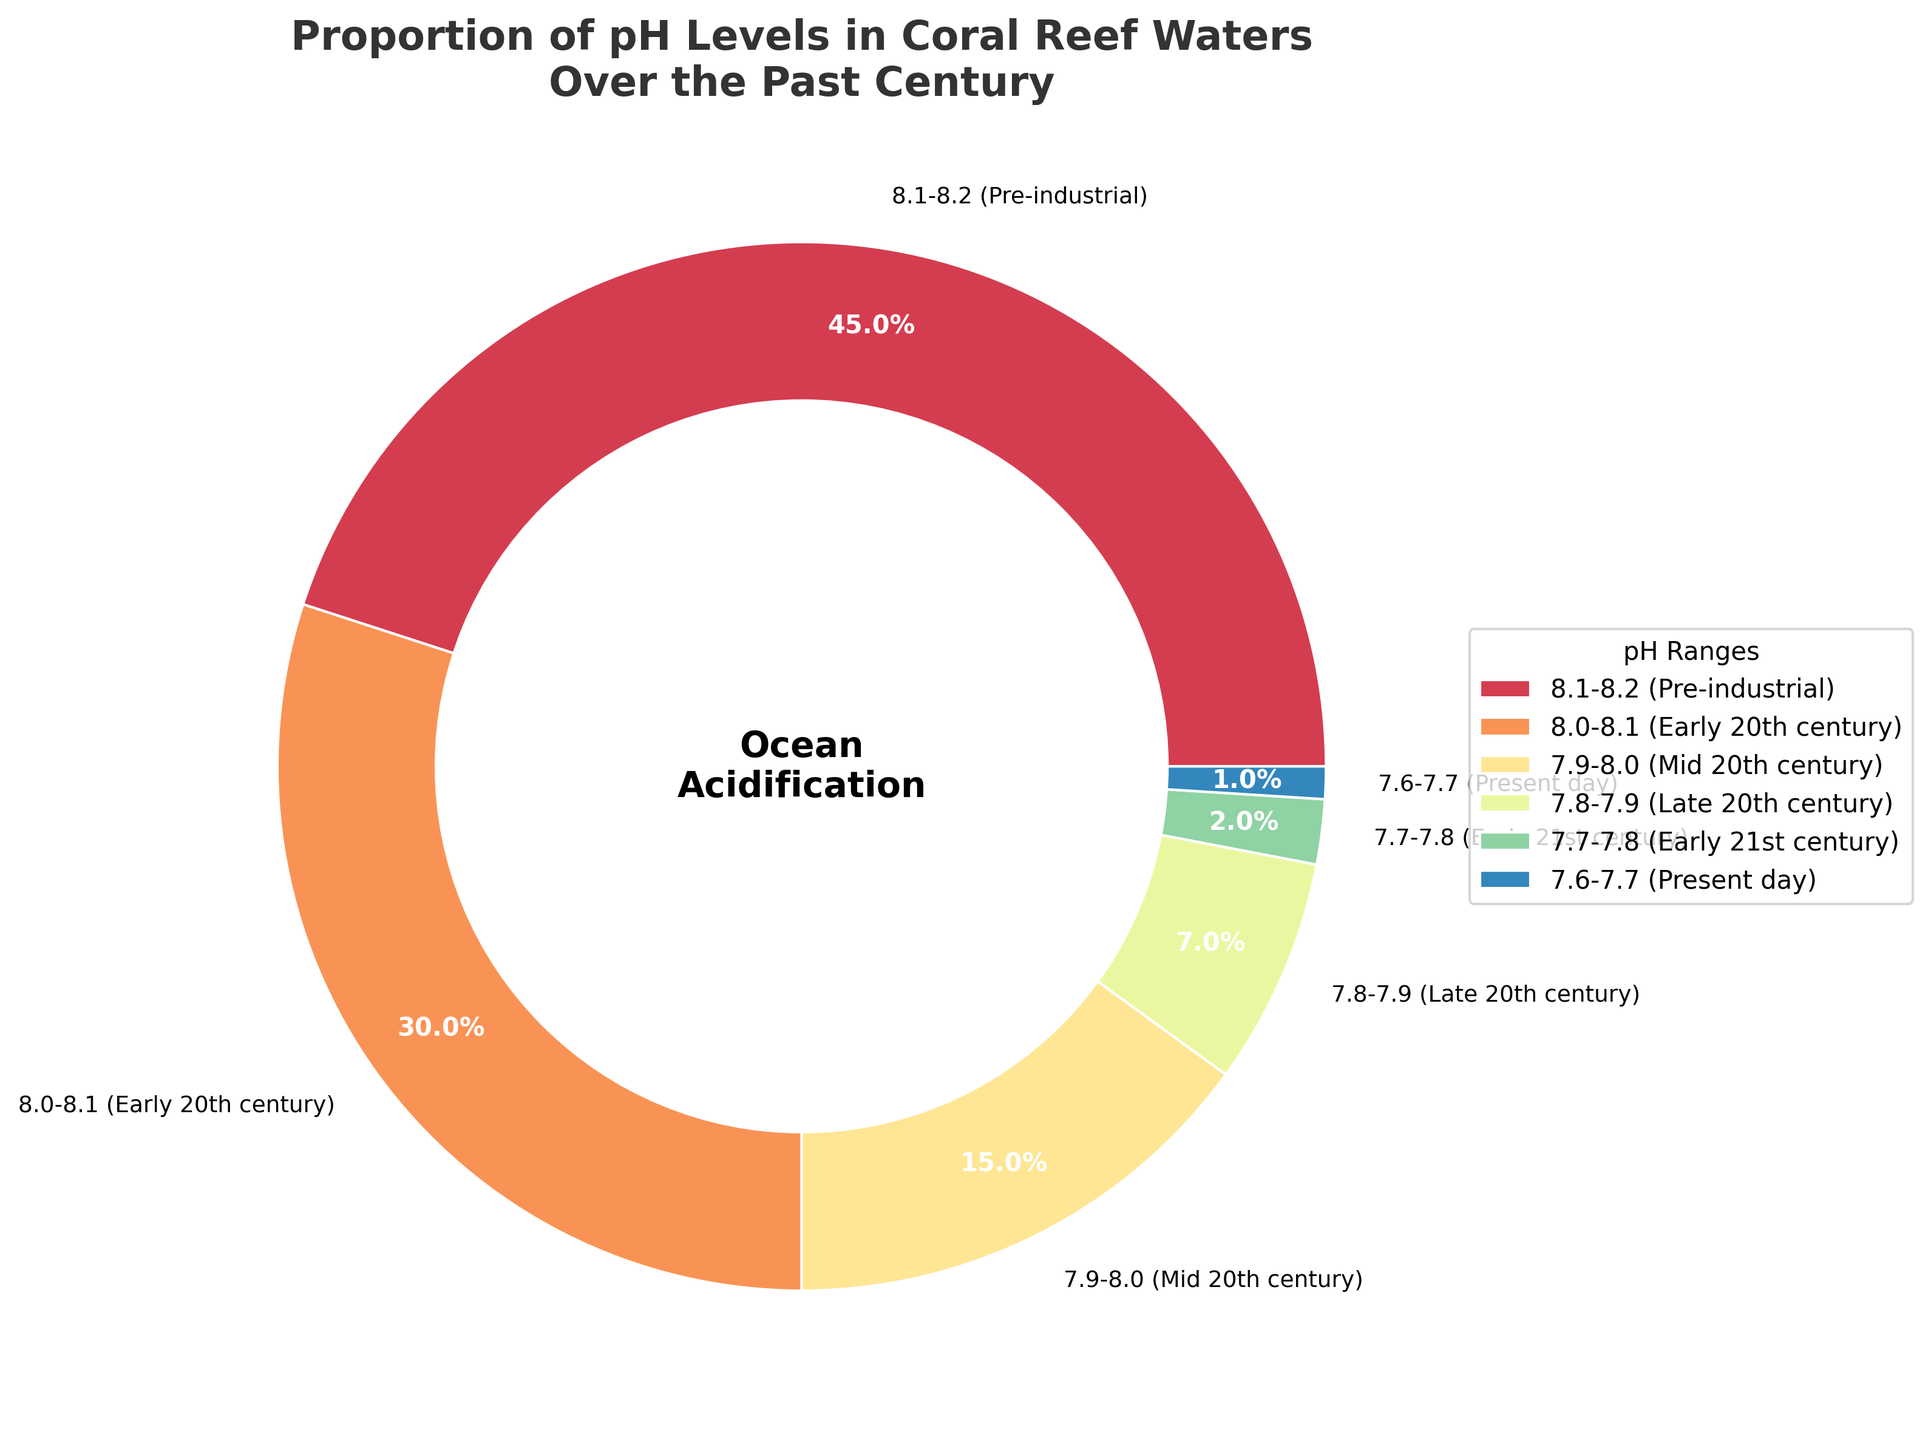What is the most common pH range in coral reef waters over the past century? The most common pH range can be identified by the largest segment in the pie chart. The 8.1-8.2 (Pre-industrial) category occupies the largest area, indicating it was the most common pH range.
Answer: 8.1-8.2 (Pre-industrial) What is the combined percentage of coral reef waters with a pH level below 8.0? To find the combined percentage, sum the percentages of the categories with pH ranges below 8.0: 15% (7.9-8.0) + 7% (7.8-7.9) + 2% (7.7-7.8) + 1% (7.6-7.7). The sum is 15 + 7 + 2 + 1 = 25%.
Answer: 25% How has the proportion of coral reefs in the pH range 7.7-7.8 changed compared to 8.1-8.2? Compare the proportion of the 7.7-7.8 range (2%) with the 8.1-8.2 range (45%). The 8.1-8.2 range is much larger than the 7.7-7.8 range.
Answer: 43% less Which pH range in the chart has the smallest representation? The segment with the smallest area represents the pH range 7.6-7.7, which is marked as 1%.
Answer: 7.6-7.7 (Present day) By how much has the proportion of coral reef waters with pH levels of 8.0-8.1 changed from the early 20th century to the present day? The chart shows that the early 20th century had 30% in 8.0-8.1, and the present day (below 8.0) has a summed percentage of 25% (all ranges below 8.0). The change from 8.0-8.1 to under 8.0 would be the difference: 30% - 25% = 5%.
Answer: Decreased by 5% Which pH range shows a visual transition to purple in the pie chart? Visual inspection shows that the color transitions to purple in the 7.9-8.0 pH range, which is marked with a more purplish shade.
Answer: 7.9-8.0 (Mid 20th century) What is the difference in percentage between Early 21st century and Mid 20th century pH levels? The Early 21st century has 2% and the Mid 20th century has 15%. The difference is 15% - 2% = 13%.
Answer: 13% What trend can be observed with the pH levels of coral reef waters over time? The pie chart shows a decreasing trend in higher pH levels (8.1-8.2) and an increasing trend in lower pH levels (below 8.0) over time, indicating ocean acidification.
Answer: Decreasing pH levels How has the proportion of the 7.8-7.9 range changed compared to the 8.0-8.1 range? The proportion of the 7.8-7.9 range (7%) is compared to the 8.0-8.1 range (30%). The 8.0-8.1 range is significantly higher.
Answer: 23% less 